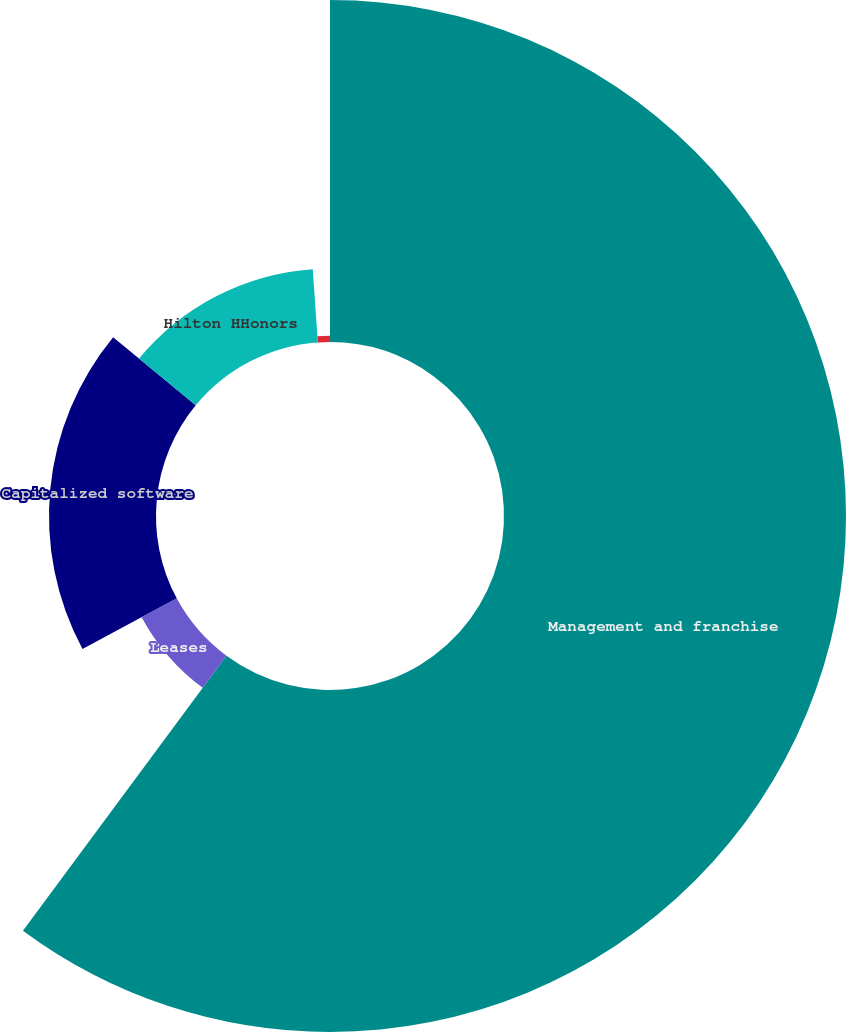<chart> <loc_0><loc_0><loc_500><loc_500><pie_chart><fcel>Management and franchise<fcel>Leases<fcel>Capitalized software<fcel>Hilton HHonors<fcel>Other<nl><fcel>60.15%<fcel>7.01%<fcel>18.82%<fcel>12.92%<fcel>1.11%<nl></chart> 